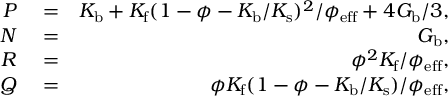<formula> <loc_0><loc_0><loc_500><loc_500>\begin{array} { r l r } { P } & = } & { K _ { b } + K _ { f } ( 1 - \phi - K _ { b } / K _ { s } ) ^ { 2 } / \phi _ { e f f } + 4 G _ { b } / 3 , } \\ { N } & = } & { G _ { b } , } \\ { R } & = } & { \phi ^ { 2 } K _ { f } / \phi _ { e f f } , } \\ { Q } & = } & { \phi K _ { f } ( 1 - \phi - K _ { b } / K _ { s } ) / \phi _ { e f f } , } \end{array}</formula> 